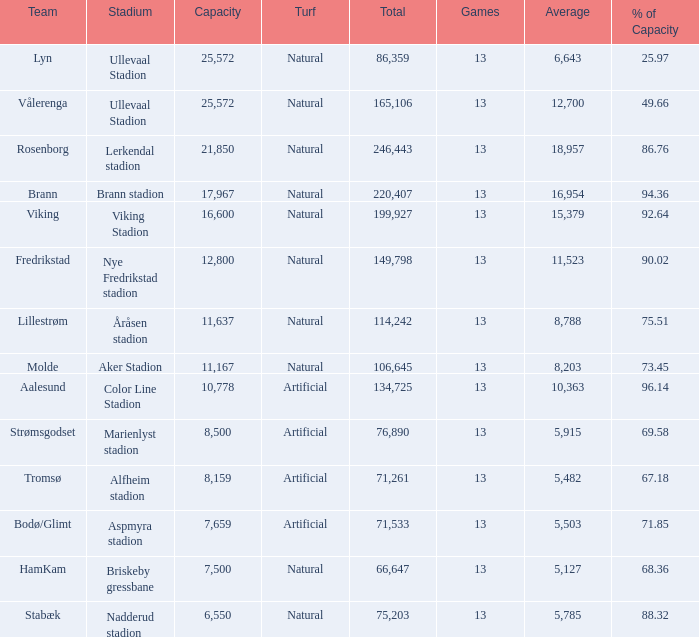14%? None. 